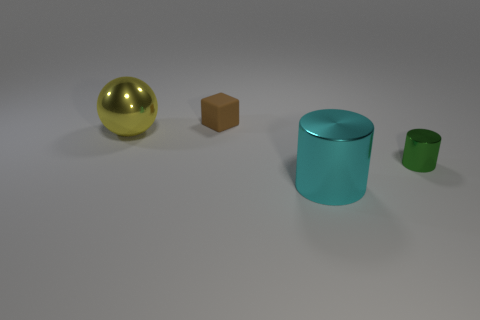Add 4 large yellow balls. How many objects exist? 8 Subtract all cubes. How many objects are left? 3 Subtract 1 cylinders. How many cylinders are left? 1 Subtract 0 yellow cylinders. How many objects are left? 4 Subtract all green balls. Subtract all cyan cylinders. How many balls are left? 1 Subtract all tiny brown matte cubes. Subtract all red matte cylinders. How many objects are left? 3 Add 3 metallic spheres. How many metallic spheres are left? 4 Add 4 red shiny things. How many red shiny things exist? 4 